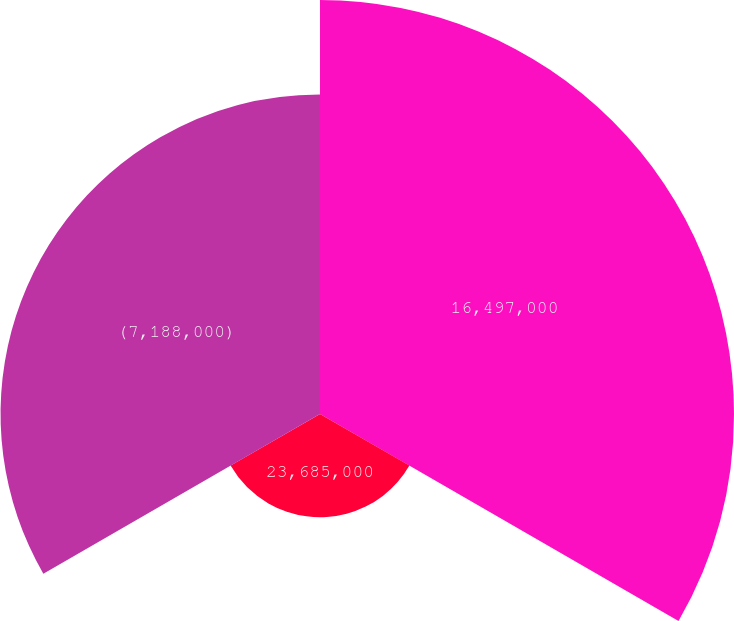<chart> <loc_0><loc_0><loc_500><loc_500><pie_chart><fcel>16,497,000<fcel>23,685,000<fcel>(7,188,000)<nl><fcel>49.48%<fcel>12.34%<fcel>38.18%<nl></chart> 